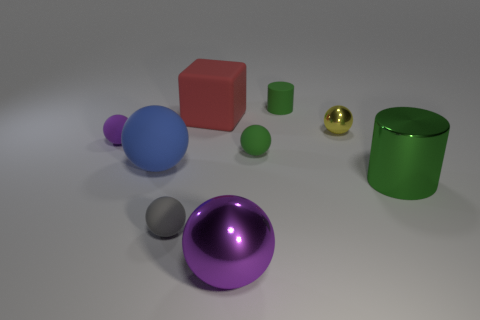Subtract all green matte balls. How many balls are left? 5 Subtract 0 gray cylinders. How many objects are left? 9 Subtract all cylinders. How many objects are left? 7 Subtract 1 cylinders. How many cylinders are left? 1 Subtract all cyan spheres. Subtract all blue blocks. How many spheres are left? 6 Subtract all blue spheres. How many blue cylinders are left? 0 Subtract all green rubber balls. Subtract all purple shiny spheres. How many objects are left? 7 Add 5 red matte things. How many red matte things are left? 6 Add 4 small shiny things. How many small shiny things exist? 5 Subtract all blue balls. How many balls are left? 5 